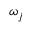<formula> <loc_0><loc_0><loc_500><loc_500>\omega _ { j }</formula> 